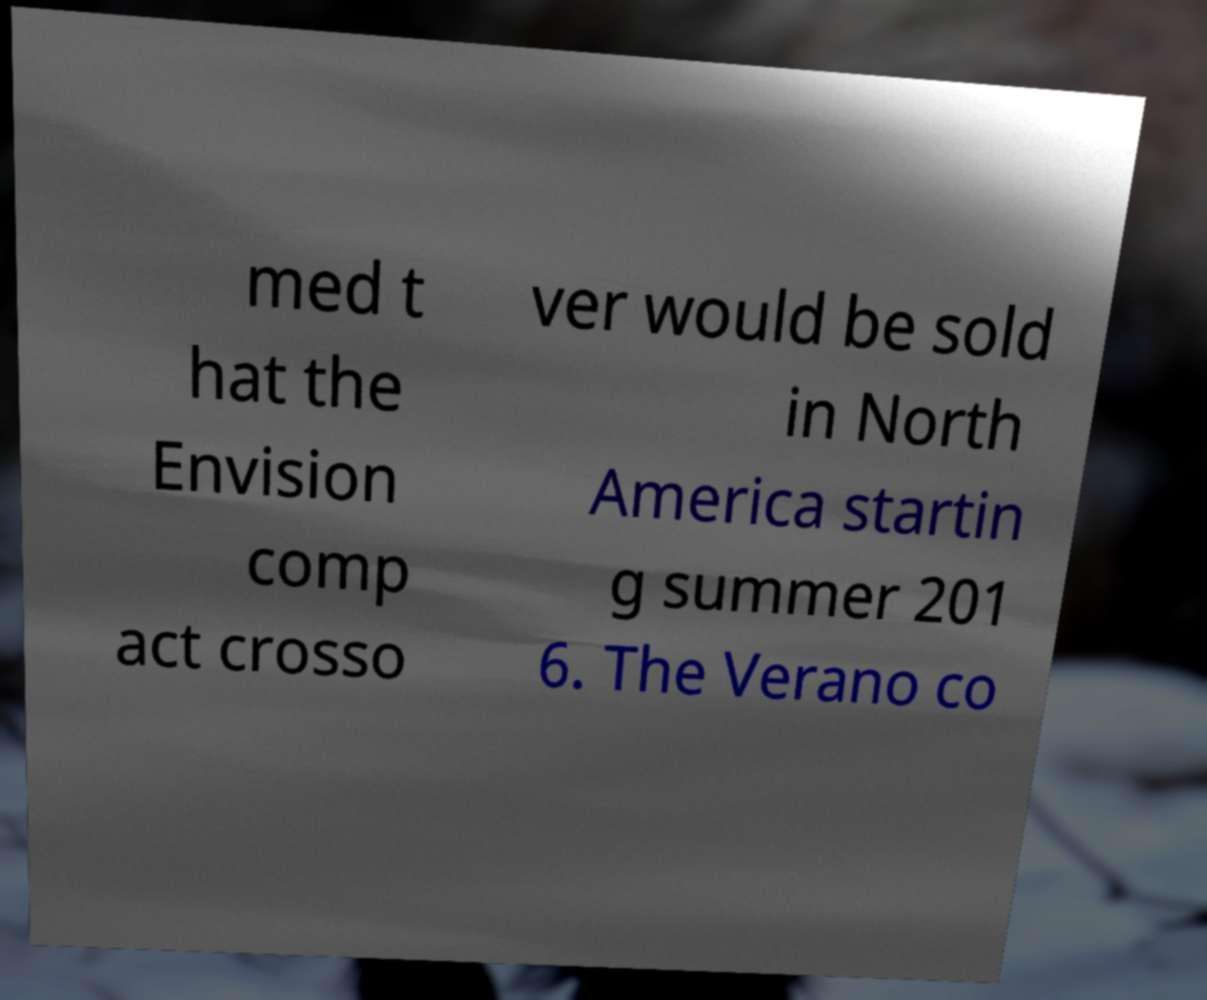Please identify and transcribe the text found in this image. med t hat the Envision comp act crosso ver would be sold in North America startin g summer 201 6. The Verano co 